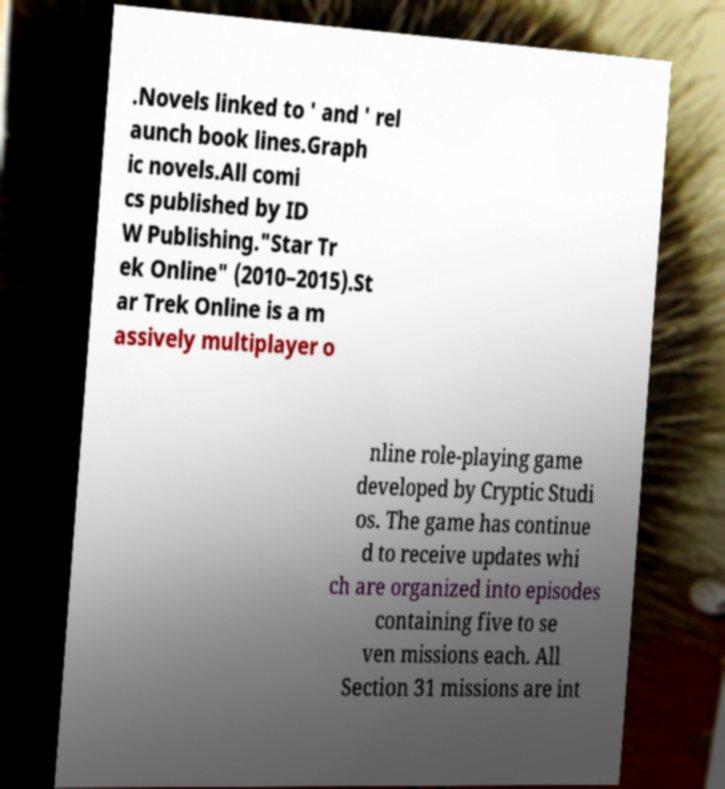Please read and relay the text visible in this image. What does it say? .Novels linked to ' and ' rel aunch book lines.Graph ic novels.All comi cs published by ID W Publishing."Star Tr ek Online" (2010–2015).St ar Trek Online is a m assively multiplayer o nline role-playing game developed by Cryptic Studi os. The game has continue d to receive updates whi ch are organized into episodes containing five to se ven missions each. All Section 31 missions are int 